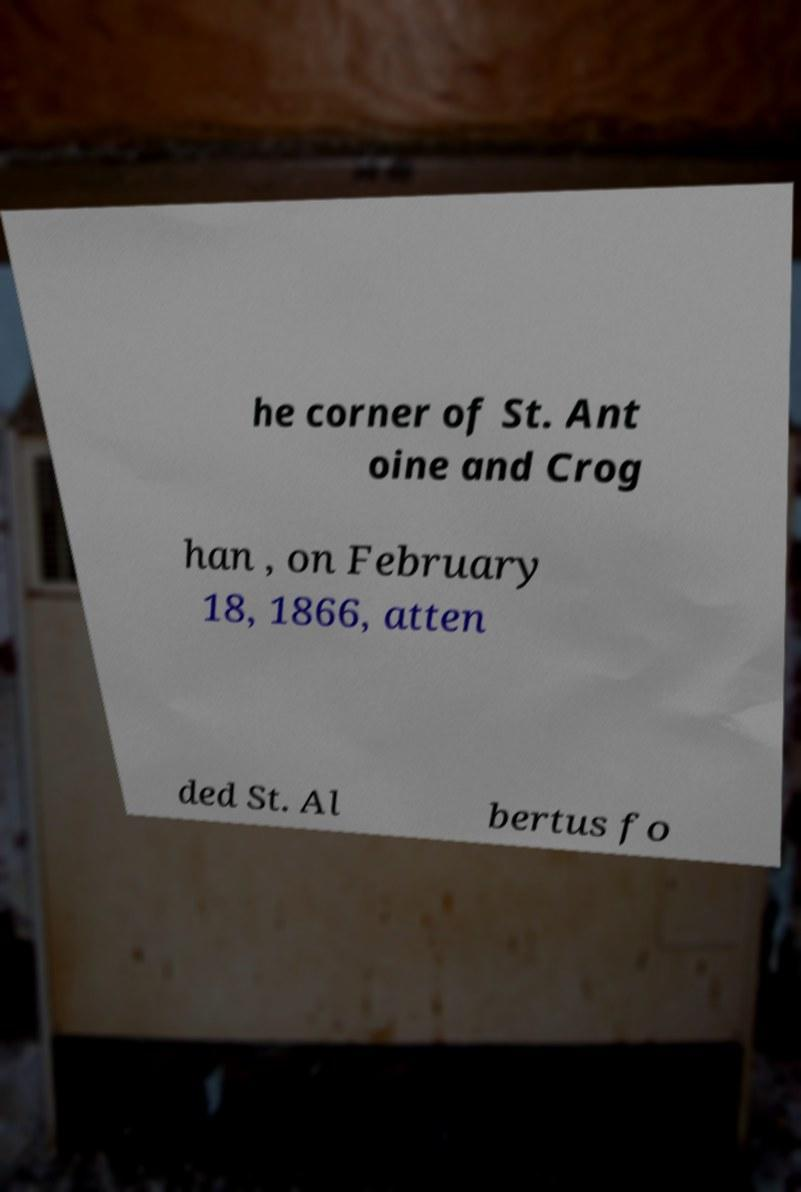For documentation purposes, I need the text within this image transcribed. Could you provide that? he corner of St. Ant oine and Crog han , on February 18, 1866, atten ded St. Al bertus fo 